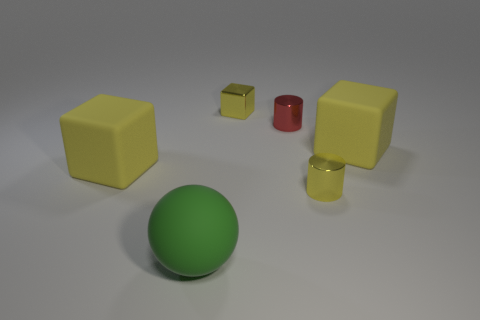Add 2 small yellow blocks. How many objects exist? 8 Subtract all spheres. How many objects are left? 5 Add 5 large brown metal cylinders. How many large brown metal cylinders exist? 5 Subtract 0 gray cylinders. How many objects are left? 6 Subtract all tiny yellow cylinders. Subtract all yellow metal cubes. How many objects are left? 4 Add 5 large matte spheres. How many large matte spheres are left? 6 